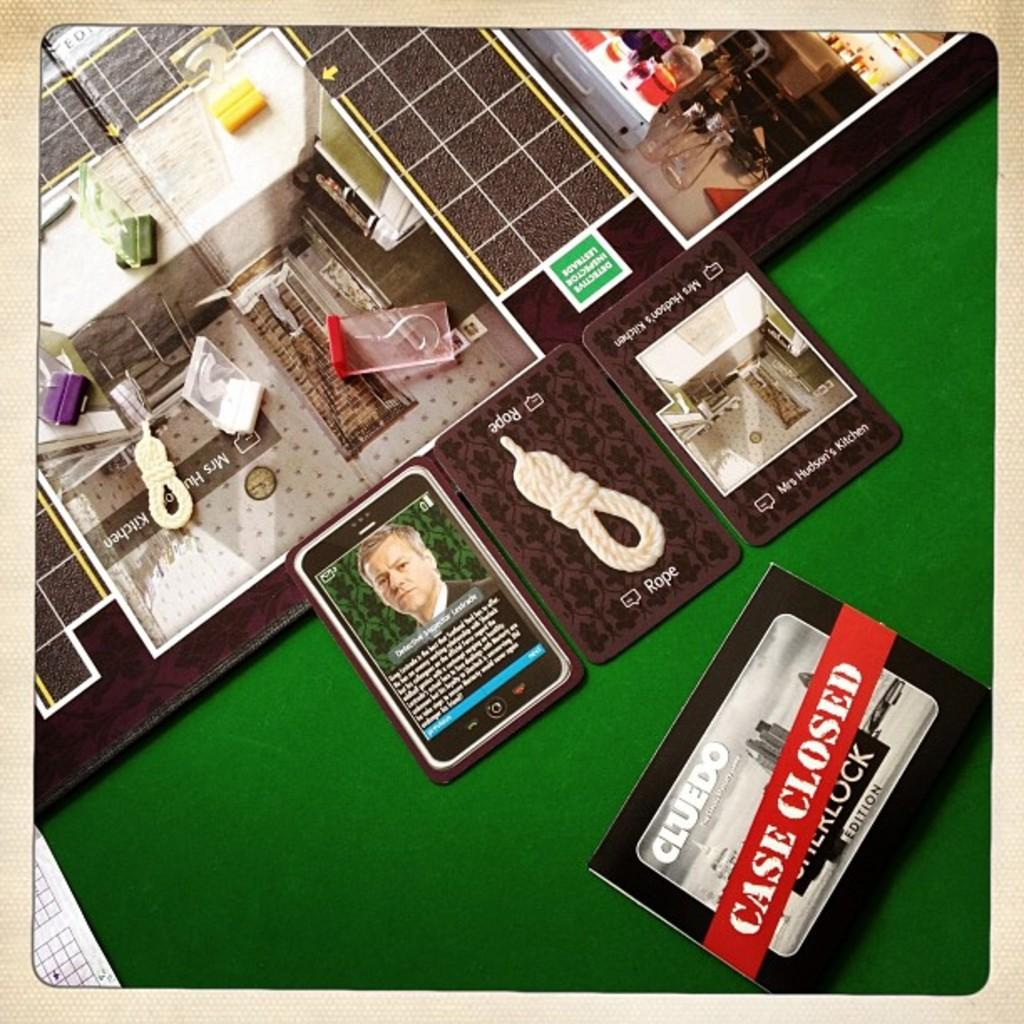Provide a one-sentence caption for the provided image. Game cards from the game Clue are laid next to each other. 